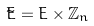Convert formula to latex. <formula><loc_0><loc_0><loc_500><loc_500>\tilde { E } = E \times \mathbb { Z } _ { n }</formula> 